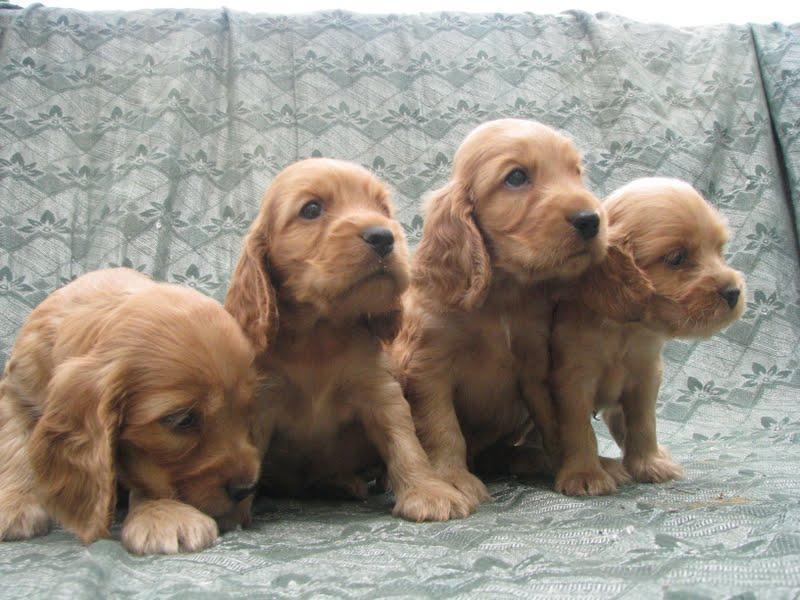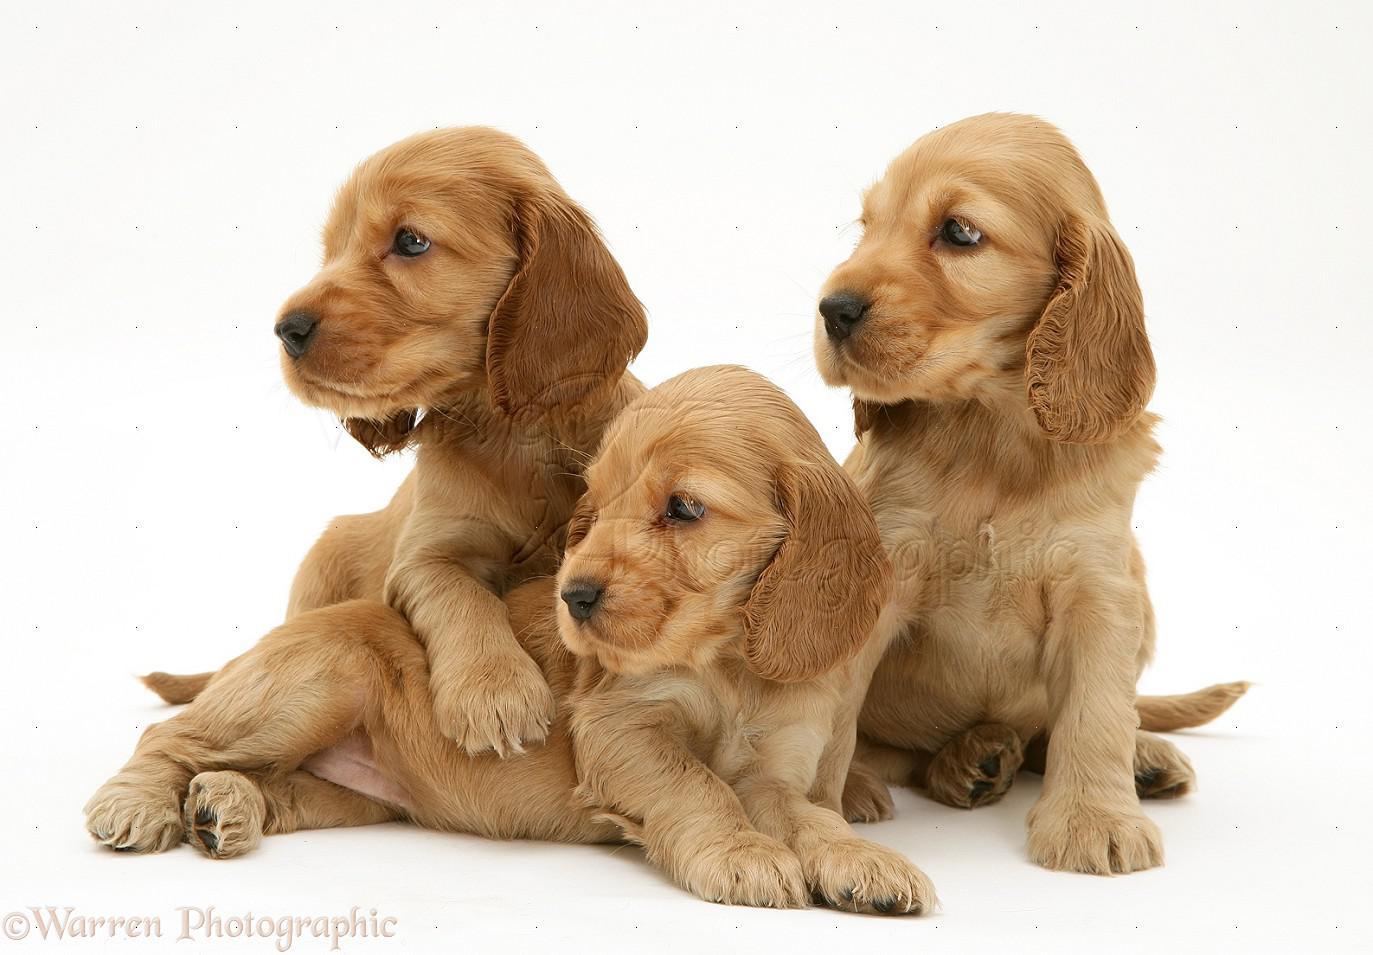The first image is the image on the left, the second image is the image on the right. Evaluate the accuracy of this statement regarding the images: "There are at least three dogs in the right image.". Is it true? Answer yes or no. Yes. The first image is the image on the left, the second image is the image on the right. For the images displayed, is the sentence "There are equal amount of dogs on the left image as the right image." factually correct? Answer yes or no. No. 